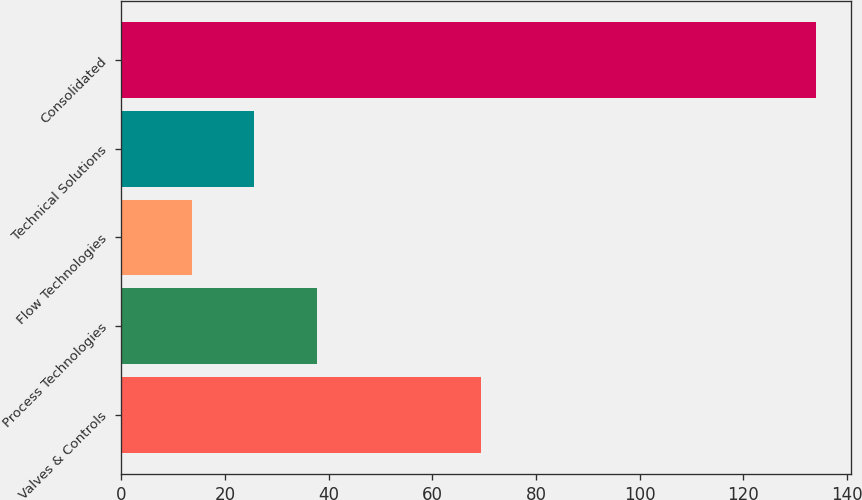Convert chart to OTSL. <chart><loc_0><loc_0><loc_500><loc_500><bar_chart><fcel>Valves & Controls<fcel>Process Technologies<fcel>Flow Technologies<fcel>Technical Solutions<fcel>Consolidated<nl><fcel>69.3<fcel>37.7<fcel>13.6<fcel>25.65<fcel>134.1<nl></chart> 